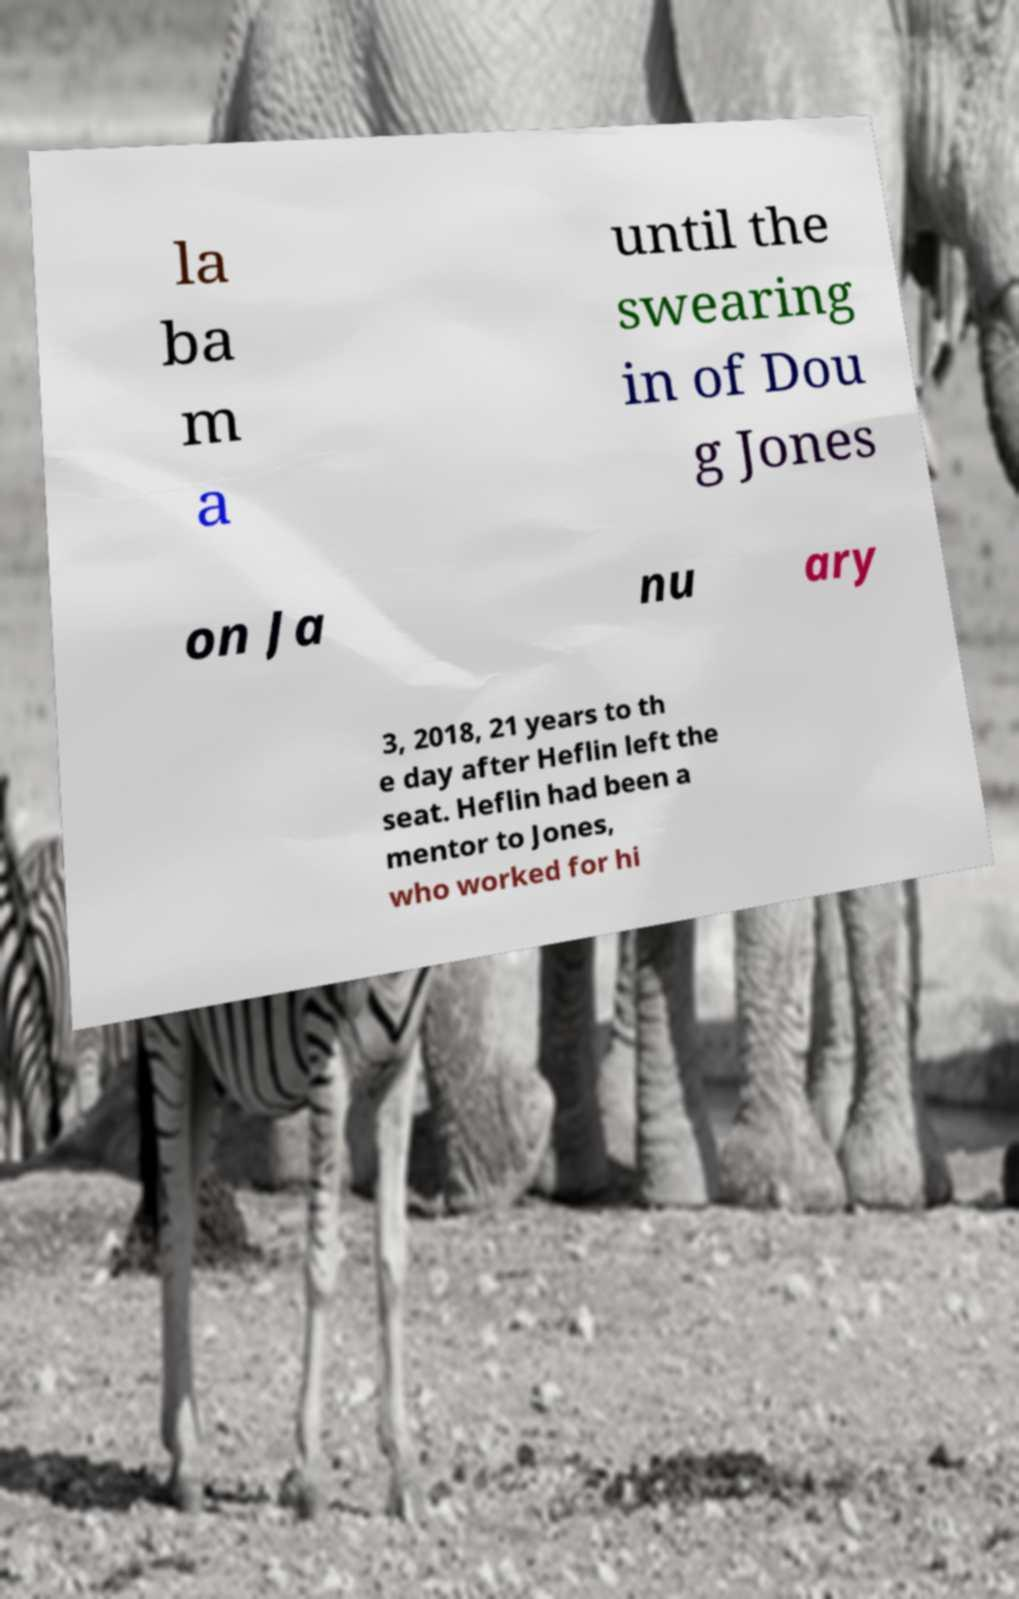Can you accurately transcribe the text from the provided image for me? la ba m a until the swearing in of Dou g Jones on Ja nu ary 3, 2018, 21 years to th e day after Heflin left the seat. Heflin had been a mentor to Jones, who worked for hi 